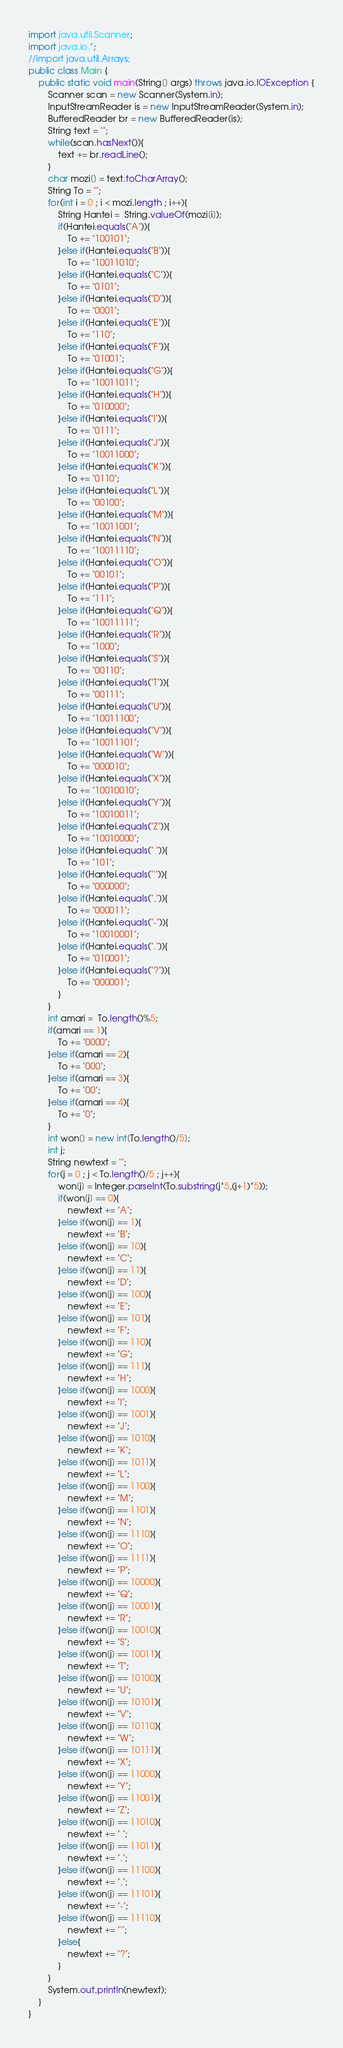Convert code to text. <code><loc_0><loc_0><loc_500><loc_500><_Java_>import java.util.Scanner;
import java.io.*;
//import java.util.Arrays;
public class Main {
	public static void main(String[] args) throws java.io.IOException {
		Scanner scan = new Scanner(System.in);
		InputStreamReader is = new InputStreamReader(System.in);
		BufferedReader br = new BufferedReader(is);
		String text = "";
		while(scan.hasNext()){
			text += br.readLine();
		}
		char mozi[] = text.toCharArray();
		String To = "";
		for(int i = 0 ; i < mozi.length ; i++){
			String Hantei =  String.valueOf(mozi[i]);
			if(Hantei.equals("A")){
				To += "100101";
			}else if(Hantei.equals("B")){
				To += "10011010";
			}else if(Hantei.equals("C")){
				To += "0101";
			}else if(Hantei.equals("D")){
				To += "0001";
			}else if(Hantei.equals("E")){
				To += "110";
			}else if(Hantei.equals("F")){
				To += "01001";
			}else if(Hantei.equals("G")){
				To += "10011011";
			}else if(Hantei.equals("H")){
				To += "010000";
			}else if(Hantei.equals("I")){
				To += "0111";
			}else if(Hantei.equals("J")){
				To += "10011000";
			}else if(Hantei.equals("K")){
				To += "0110";
			}else if(Hantei.equals("L")){
				To += "00100";
			}else if(Hantei.equals("M")){
				To += "10011001";
			}else if(Hantei.equals("N")){
				To += "10011110";
			}else if(Hantei.equals("O")){
				To += "00101";
			}else if(Hantei.equals("P")){
				To += "111";
			}else if(Hantei.equals("Q")){
				To += "10011111";
			}else if(Hantei.equals("R")){
				To += "1000";
			}else if(Hantei.equals("S")){
				To += "00110";
			}else if(Hantei.equals("T")){
				To += "00111";
			}else if(Hantei.equals("U")){
				To += "10011100";
			}else if(Hantei.equals("V")){
				To += "10011101";
			}else if(Hantei.equals("W")){
				To += "000010";
			}else if(Hantei.equals("X")){
				To += "10010010";
			}else if(Hantei.equals("Y")){
				To += "10010011";
			}else if(Hantei.equals("Z")){
				To += "10010000";
			}else if(Hantei.equals(" ")){
				To += "101";
			}else if(Hantei.equals("'")){
				To += "000000";
			}else if(Hantei.equals(",")){
				To += "000011";
			}else if(Hantei.equals("-")){
				To += "10010001";
			}else if(Hantei.equals(".")){
				To += "010001";
			}else if(Hantei.equals("?")){
				To += "000001";
			}
		}
		int amari =  To.length()%5;
		if(amari == 1){
			To += "0000";
		}else if(amari == 2){
			To += "000";
		}else if(amari == 3){
			To += "00";
		}else if(amari == 4){
			To += "0";
		}
		int won[] = new int[To.length()/5];
		int j;
		String newtext = "";
		for(j = 0 ; j < To.length()/5 ; j++){
			won[j] = Integer.parseInt(To.substring(j*5,(j+1)*5));
			if(won[j] == 0){
				newtext += "A";
			}else if(won[j] == 1){
				newtext += "B";
			}else if(won[j] == 10){
				newtext += "C";
			}else if(won[j] == 11){
				newtext += "D";
			}else if(won[j] == 100){
				newtext += "E";
			}else if(won[j] == 101){
				newtext += "F";
			}else if(won[j] == 110){
				newtext += "G";
			}else if(won[j] == 111){
				newtext += "H";
			}else if(won[j] == 1000){
				newtext += "I";
			}else if(won[j] == 1001){
				newtext += "J";
			}else if(won[j] == 1010){
				newtext += "K";
			}else if(won[j] == 1011){
				newtext += "L";
			}else if(won[j] == 1100){
				newtext += "M";
			}else if(won[j] == 1101){
				newtext += "N";
			}else if(won[j] == 1110){
				newtext += "O";
			}else if(won[j] == 1111){
				newtext += "P";
			}else if(won[j] == 10000){
				newtext += "Q";
			}else if(won[j] == 10001){
				newtext += "R";
			}else if(won[j] == 10010){
				newtext += "S";
			}else if(won[j] == 10011){
				newtext += "T";
			}else if(won[j] == 10100){
				newtext += "U";
			}else if(won[j] == 10101){
				newtext += "V";
			}else if(won[j] == 10110){
				newtext += "W";
			}else if(won[j] == 10111){
				newtext += "X";
			}else if(won[j] == 11000){
				newtext += "Y";
			}else if(won[j] == 11001){
				newtext += "Z";
			}else if(won[j] == 11010){
				newtext += " ";
			}else if(won[j] == 11011){
				newtext += ".";
			}else if(won[j] == 11100){
				newtext += ",";
			}else if(won[j] == 11101){
				newtext += "-";
			}else if(won[j] == 11110){
				newtext += "'";
			}else{
				newtext += "?";
			}
		}
		System.out.println(newtext);
	}
}</code> 